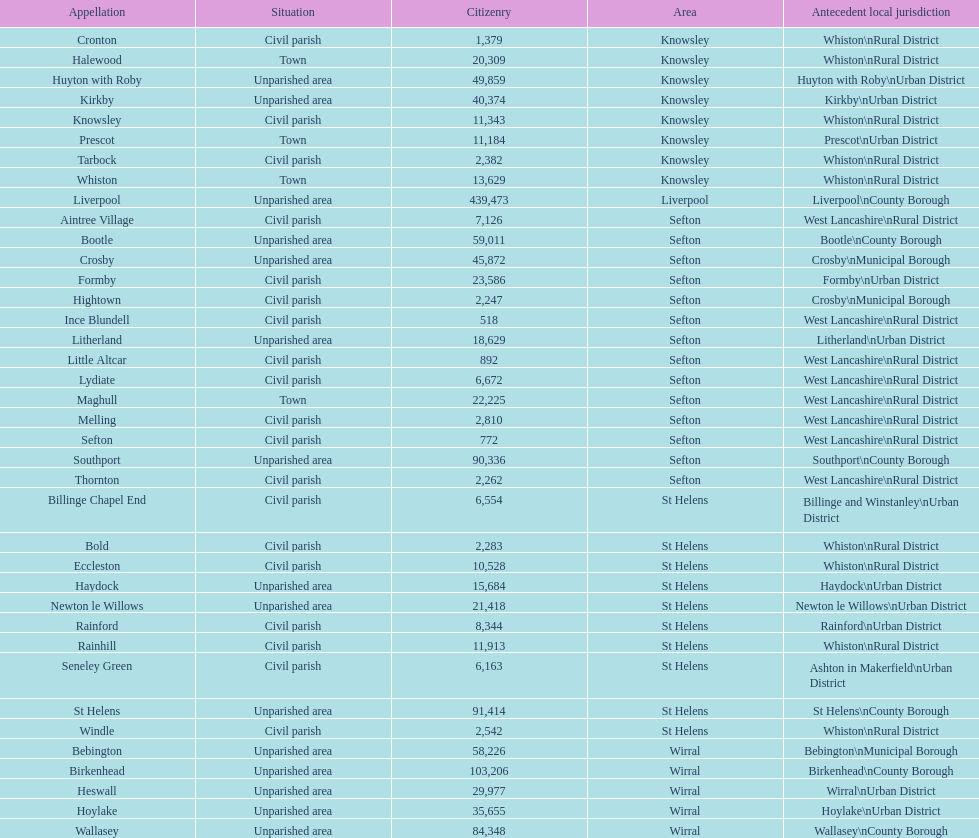What is the largest area in terms of population? Liverpool. 